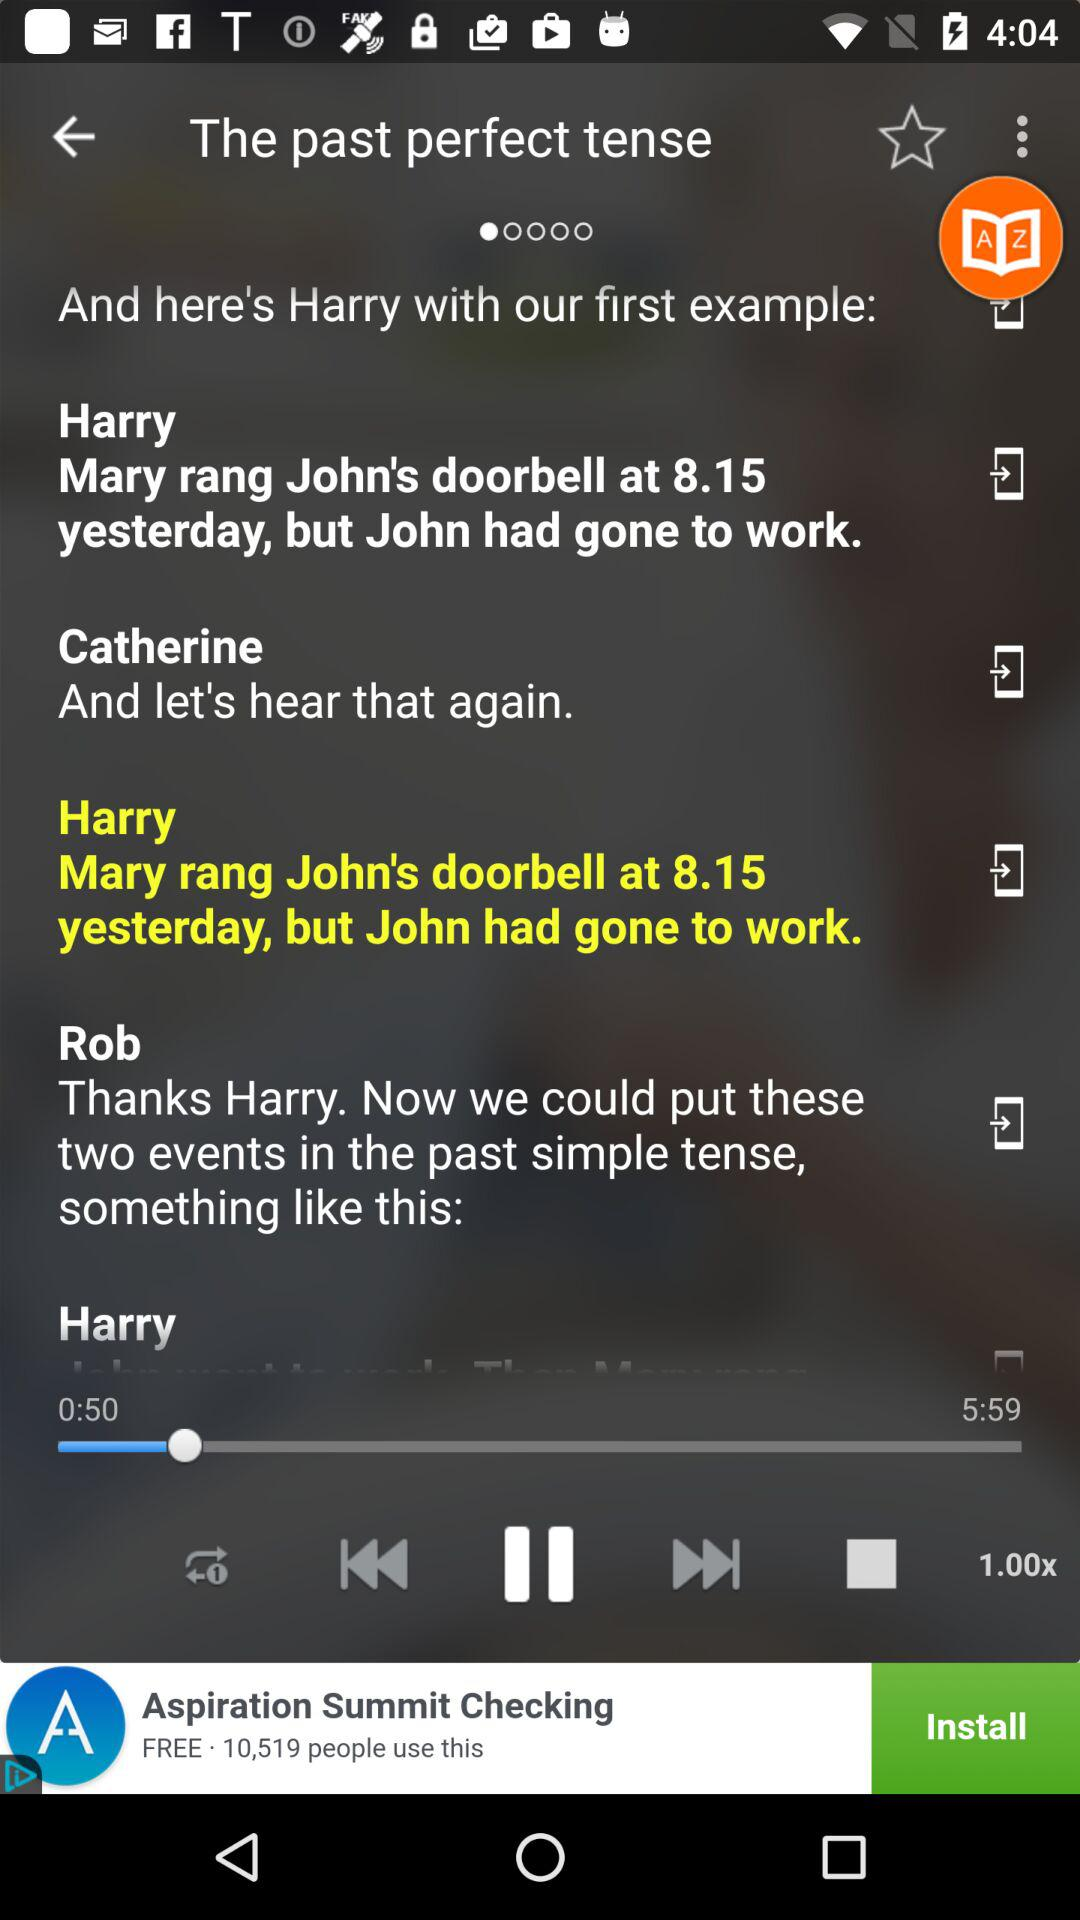Which audio is currently playing? The currently playing audio is "The past perfect tense". 